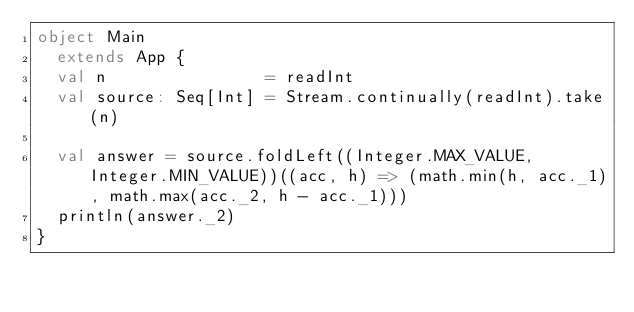<code> <loc_0><loc_0><loc_500><loc_500><_Scala_>object Main
  extends App {
  val n                = readInt
  val source: Seq[Int] = Stream.continually(readInt).take(n)

  val answer = source.foldLeft((Integer.MAX_VALUE, Integer.MIN_VALUE))((acc, h) => (math.min(h, acc._1), math.max(acc._2, h - acc._1)))
  println(answer._2)
}
</code> 